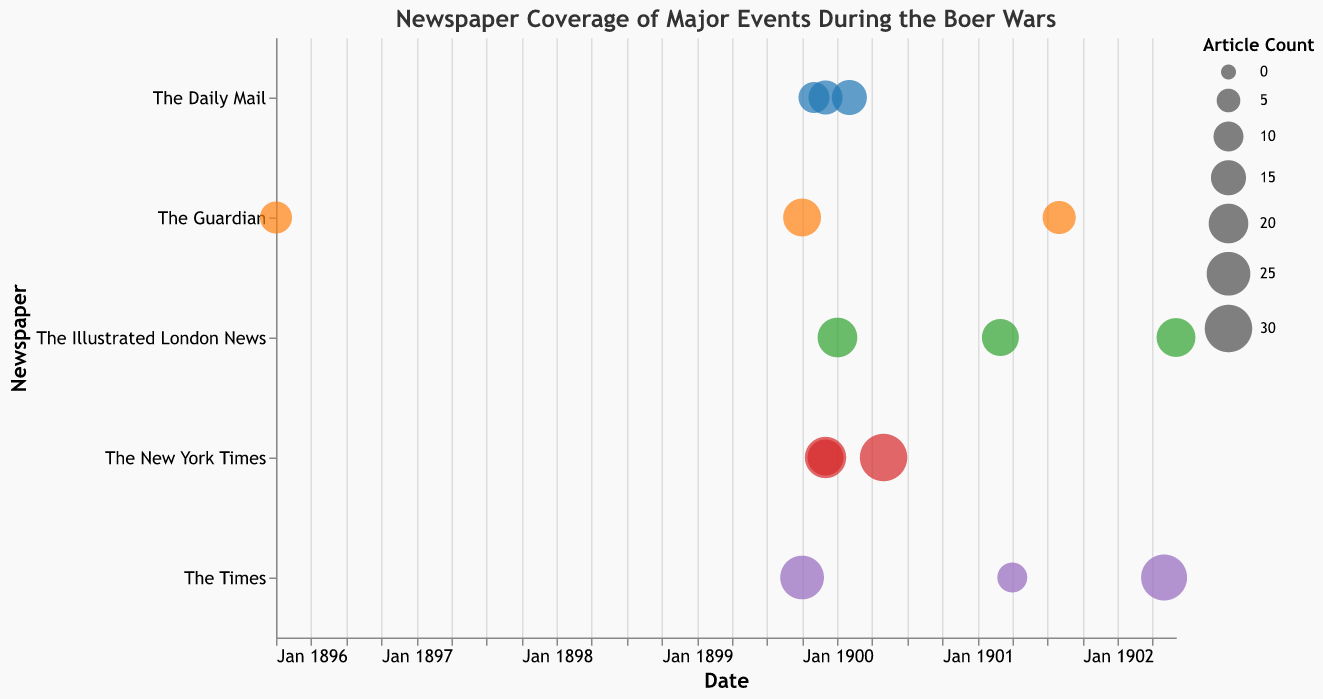What is the largest bubble in the chart, and what event does it correspond to? You need to identify the bubble with the largest size. The size scale is based on the article count, so the largest bubble represents the event with the highest article count. According to the data, the event "Siege of Mafeking" in "The New York Times" in May 1900 has the highest article count of 30.
Answer: Siege of Mafeking Which newspaper reported the "Peace of Vereeniging" and how many articles were published? Locate the bubble corresponding to the event "Peace of Vereeniging" and check its y-axis value (newspaper) and bubble size (article count). According to the data, the "Peace of Vereeniging" event was covered by "The Times" with an article count of 28.
Answer: The Times, 28 What are the two events covered by "The Guardian" in 1899, and how many articles were published for each? Identify the bubbles with the newspaper "The Guardian" (y-axis), and within those bubbles, find the ones from 1899 on the x-axis. The events are "Second Boer War Declaration" in October 1899 with 18 articles and "Jameson Raid" in January 1896 with 12 articles.
Answer: Second Boer War Declaration: 18, Jameson Raid: 12 Which event had the smallest article count, and how many articles were published? Find the smallest bubble in the chart regarding size, which represents the event with the least articles. According to the data, the smallest article count is 10 for the "Scorched Earth Policy" reported by "The Times" in April 1901.
Answer: Scorched Earth Policy, 10 What is the total number of articles published about the "Battle of Spion Kop" and "Battle of Magersfontein"? Sum the article counts for both events: "Battle of Spion Kop" (20 articles) and "Battle of Magersfontein" (14 articles). The total is 20 + 14 = 34 articles.
Answer: 34 Which newspaper covered the "Boer Guerrilla Tactics," and in what month and year was it covered? Locate the bubble for the "Boer Guerrilla Tactics" event and check its y-axis value (newspaper) and x-axis value (date). The event was covered by "The Illustrated London News" in March 1901.
Answer: The Illustrated London News, March 1901 Between "The Times" and "The Daily Mail," which newspaper has a higher average article count per event? Calculate the average article count for each newspaper:
- The Times: (25 + 28 + 10) / 3 = 63 / 3 = 21
- The Daily Mail: (15 + 14 + 11) / 3 = 40 / 3 ≈ 13.33
"The Times" has a higher average article count per event.
Answer: The Times How many events were covered in December 1899, and which events were they? Identify the bubbles corresponding to December 1899 in the x-axis and count them. According to the data, three events were covered: "Battle of Colenso" (New York Times), "Battle of Magersfontein" (Daily Mail), and "Black Week" (New York Times).
Answer: 3, Battle of Colenso, Battle of Magersfontein, Black Week 